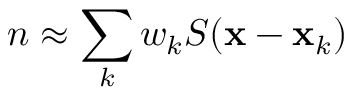<formula> <loc_0><loc_0><loc_500><loc_500>n \approx \sum _ { k } w _ { k } S ( { \mathbf x } - { \mathbf x } _ { k } )</formula> 